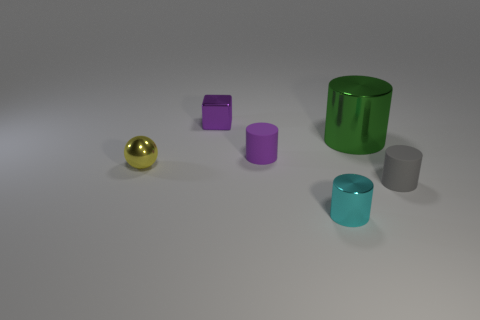Subtract all purple cylinders. How many cylinders are left? 3 Subtract all small cylinders. How many cylinders are left? 1 Add 2 things. How many objects exist? 8 Subtract all brown cylinders. Subtract all gray balls. How many cylinders are left? 4 Subtract all cylinders. How many objects are left? 2 Add 5 tiny metallic cylinders. How many tiny metallic cylinders are left? 6 Add 2 big cylinders. How many big cylinders exist? 3 Subtract 0 yellow blocks. How many objects are left? 6 Subtract all purple cylinders. Subtract all purple things. How many objects are left? 3 